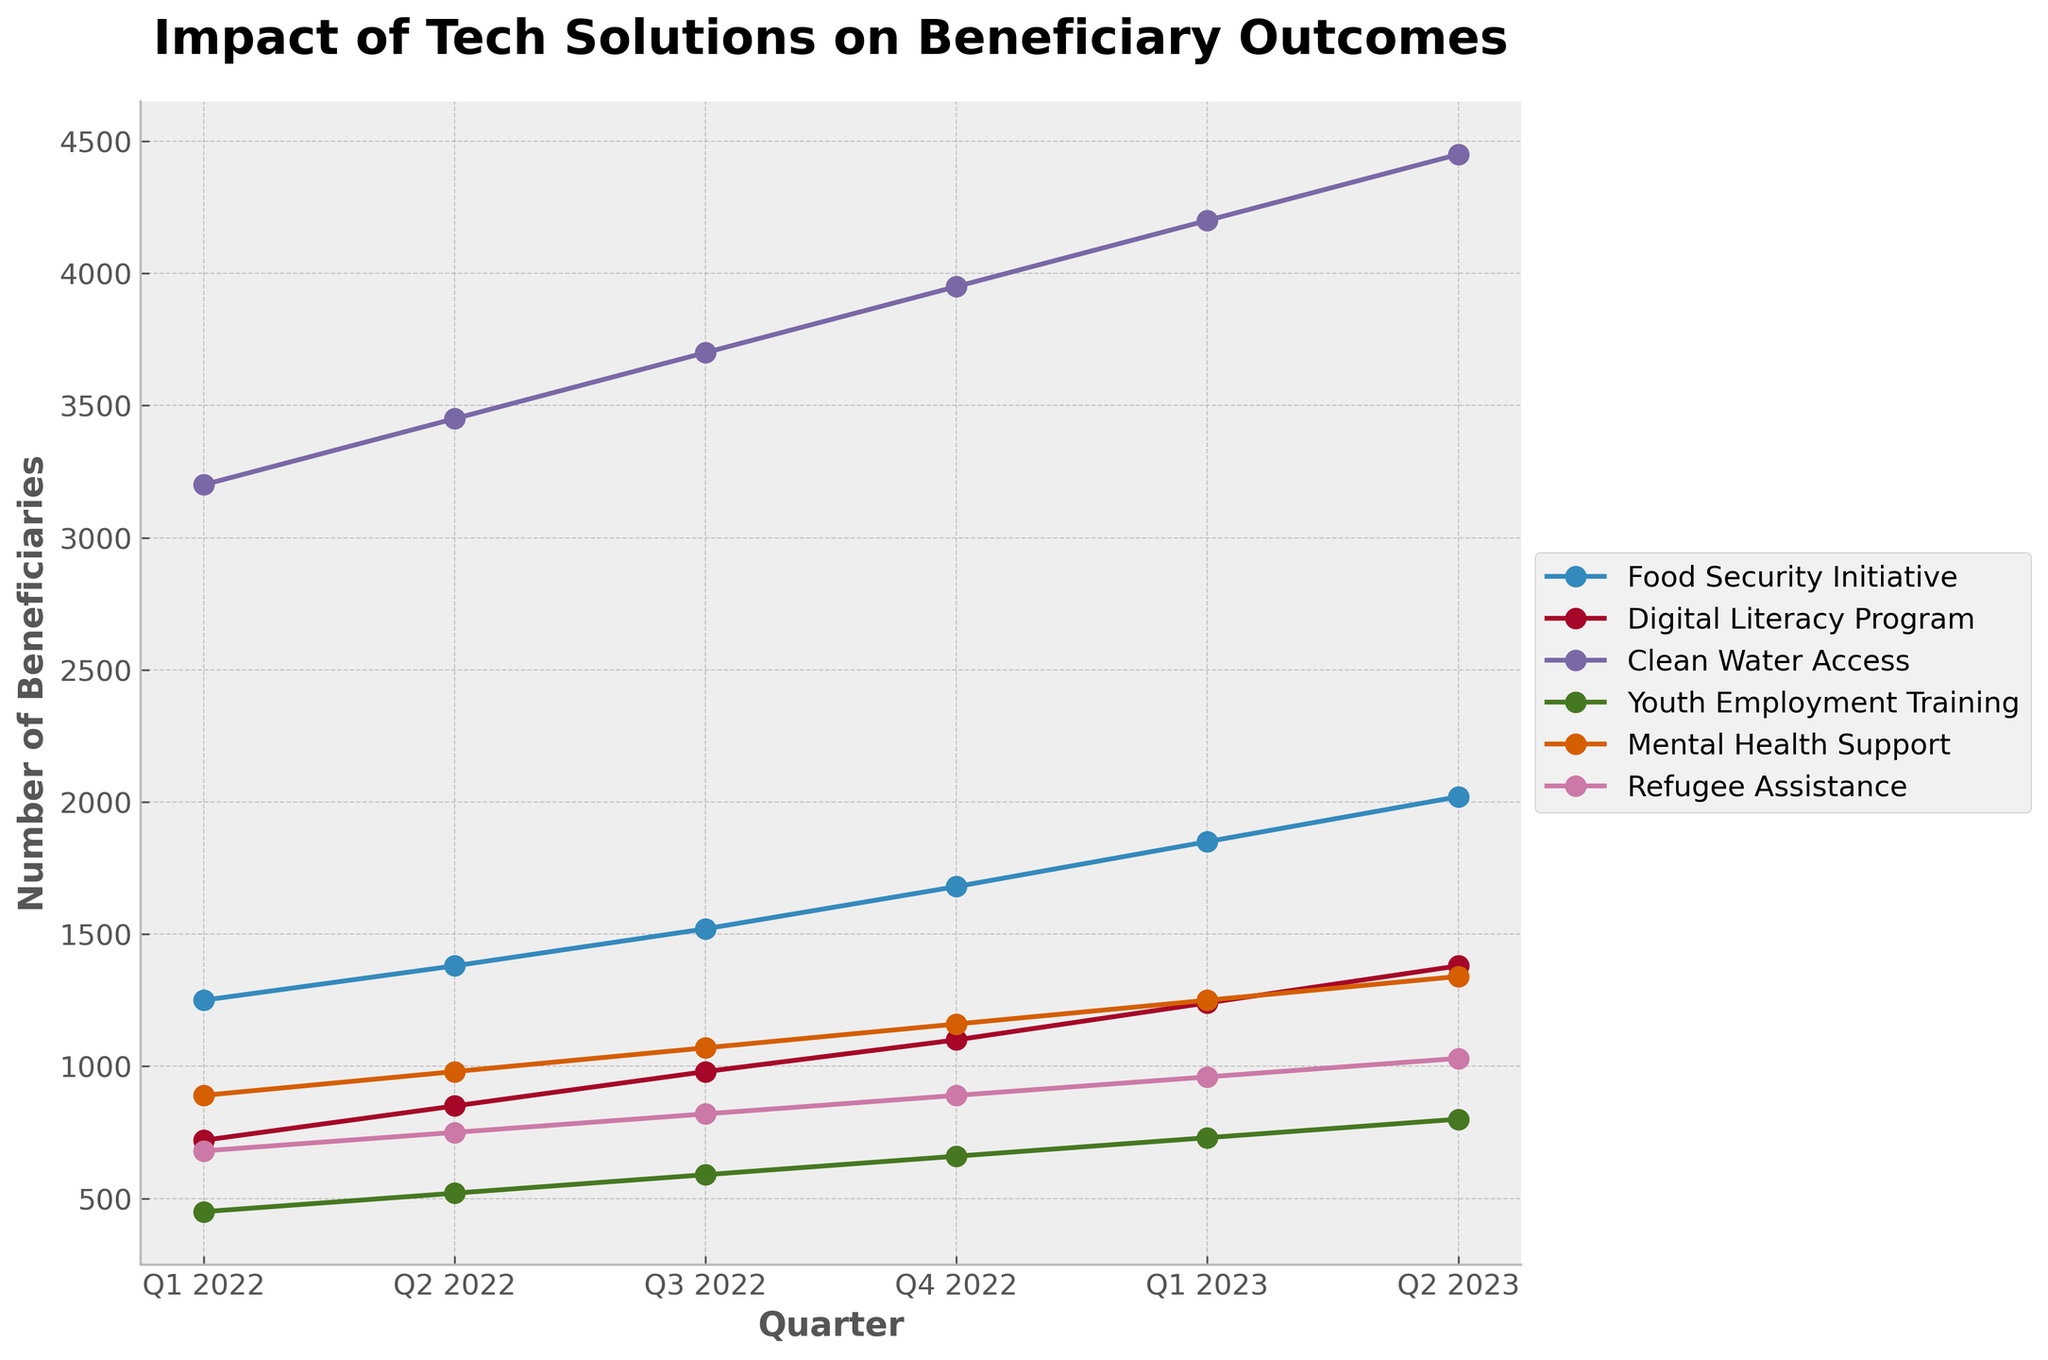Which program experienced the highest increase in the number of beneficiaries from Q1 2022 to Q2 2023? First, find the increase for each program by subtracting the number of beneficiaries in Q1 2022 from Q2 2023. For the Food Security Initiative: 2020 - 1250 = 770; Digital Literacy Program: 1380 - 720 = 660; Clean Water Access: 4450 - 3200 = 1250; Youth Employment Training: 800 - 450 = 350; Mental Health Support: 1340 - 890 = 450; Refugee Assistance: 1030 - 680 = 350. Clean Water Access has the highest increase of 1250
Answer: Clean Water Access Which two programs had the closest number of beneficiaries in Q4 2022? Compare the number of beneficiaries in Q4 2022 for all programs. Food Security Initiative: 1680; Digital Literacy Program: 1100; Clean Water Access: 3950; Youth Employment Training: 660; Mental Health Support: 1160; Refugee Assistance: 890. The closest numbers are for Mental Health Support (1160) and Digital Literacy Program (1100), which differ by only 60.
Answer: Digital Literacy Program and Mental Health Support Between Q2 2022 and Q4 2022, which program observed more beneficiaries: Refugee Assistance or Youth Employment Training? Compare the beneficiaries of both programs in the given quarters. In Q2 2022: Refugee Assistance: 750, Youth Employment Training: 520. In Q4 2022: Refugee Assistance: 890, Youth Employment Training: 660. Refugee Assistance had more beneficiaries in both quarters.
Answer: Refugee Assistance What is the average number of beneficiaries in Q1 2023 across all programs? Add the number of beneficiaries in Q1 2023 for all programs and divide by the number of programs. (1850 + 1240 + 4200 + 730 + 1250 + 960) = 10230, then 10230 / 6 ≈ 1705
Answer: 1705 Rank the programs based on the number of beneficiaries in Q3 2022 from highest to lowest List the number of beneficiaries for each program in Q3 2022 and then sort them. Clean Water Access: 3700, Food Security Initiative: 1520, Digital Literacy Program: 980, Youth Employment Training: 590, Mental Health Support: 1070, Refugee Assistance: 820. Sorted order: Clean Water Access, Food Security Initiative, Mental Health Support, Digital Literacy Program, Youth Employment Training, Refugee Assistance
Answer: Clean Water Access, Food Security Initiative, Mental Health Support, Digital Literacy Program, Youth Employment Training, Refugee Assistance How much did the number of beneficiaries increase for the Youth Employment Training program from Q1 2022 to Q2 2023, in percentage terms? First find the absolute increase: 800 - 450 = 350. Then divide the increase by the initial value and multiply by 100 to convert to percentage: (350 / 450) * 100 ≈ 77.78%
Answer: 77.78% Which quarter showed the smallest increase in beneficiaries for the Digital Literacy Program? Calculate the increase between each consecutive quarter for the Digital Literacy Program: Q1 to Q2: 130, Q2 to Q3: 130, Q3 to Q4: 120, Q4 to Q1 2023: 140, Q1 to Q2 2023: 140. The smallest increase occurred between Q3 2022 and Q4 2022 with an increase of 120 beneficiaries
Answer: Q3 2022 to Q4 2022 Among all the programs, which one had the second-largest number of beneficiaries in Q2 2023? List the number of beneficiaries for each program in Q2 2023 and identify the second largest: Clean Water Access: 4450, Food Security Initiative: 2020, Digital Literacy Program: 1380, Youth Employment Training: 800, Mental Health Support: 1340, Refugee Assistance: 1030. The second-largest is the Food Security Initiative with 2020 beneficiaries
Answer: Food Security Initiative 